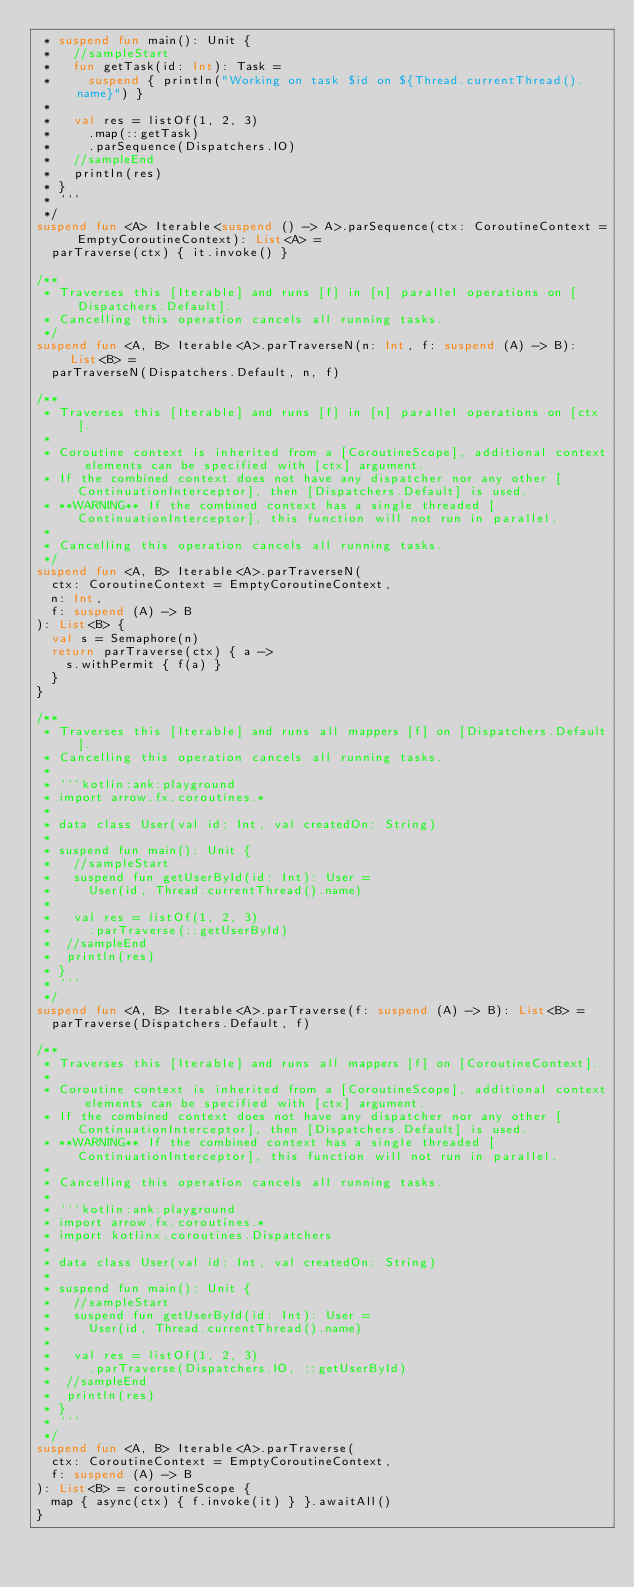Convert code to text. <code><loc_0><loc_0><loc_500><loc_500><_Kotlin_> * suspend fun main(): Unit {
 *   //sampleStart
 *   fun getTask(id: Int): Task =
 *     suspend { println("Working on task $id on ${Thread.currentThread().name}") }
 *
 *   val res = listOf(1, 2, 3)
 *     .map(::getTask)
 *     .parSequence(Dispatchers.IO)
 *   //sampleEnd
 *   println(res)
 * }
 * ```
 */
suspend fun <A> Iterable<suspend () -> A>.parSequence(ctx: CoroutineContext = EmptyCoroutineContext): List<A> =
  parTraverse(ctx) { it.invoke() }

/**
 * Traverses this [Iterable] and runs [f] in [n] parallel operations on [Dispatchers.Default].
 * Cancelling this operation cancels all running tasks.
 */
suspend fun <A, B> Iterable<A>.parTraverseN(n: Int, f: suspend (A) -> B): List<B> =
  parTraverseN(Dispatchers.Default, n, f)

/**
 * Traverses this [Iterable] and runs [f] in [n] parallel operations on [ctx].
 *
 * Coroutine context is inherited from a [CoroutineScope], additional context elements can be specified with [ctx] argument.
 * If the combined context does not have any dispatcher nor any other [ContinuationInterceptor], then [Dispatchers.Default] is used.
 * **WARNING** If the combined context has a single threaded [ContinuationInterceptor], this function will not run in parallel.
 *
 * Cancelling this operation cancels all running tasks.
 */
suspend fun <A, B> Iterable<A>.parTraverseN(
  ctx: CoroutineContext = EmptyCoroutineContext,
  n: Int,
  f: suspend (A) -> B
): List<B> {
  val s = Semaphore(n)
  return parTraverse(ctx) { a ->
    s.withPermit { f(a) }
  }
}

/**
 * Traverses this [Iterable] and runs all mappers [f] on [Dispatchers.Default].
 * Cancelling this operation cancels all running tasks.
 *
 * ```kotlin:ank:playground
 * import arrow.fx.coroutines.*
 *
 * data class User(val id: Int, val createdOn: String)
 *
 * suspend fun main(): Unit {
 *   //sampleStart
 *   suspend fun getUserById(id: Int): User =
 *     User(id, Thread.currentThread().name)
 *
 *   val res = listOf(1, 2, 3)
 *     .parTraverse(::getUserById)
 *  //sampleEnd
 *  println(res)
 * }
 * ```
 */
suspend fun <A, B> Iterable<A>.parTraverse(f: suspend (A) -> B): List<B> =
  parTraverse(Dispatchers.Default, f)

/**
 * Traverses this [Iterable] and runs all mappers [f] on [CoroutineContext].
 *
 * Coroutine context is inherited from a [CoroutineScope], additional context elements can be specified with [ctx] argument.
 * If the combined context does not have any dispatcher nor any other [ContinuationInterceptor], then [Dispatchers.Default] is used.
 * **WARNING** If the combined context has a single threaded [ContinuationInterceptor], this function will not run in parallel.
 *
 * Cancelling this operation cancels all running tasks.
 *
 * ```kotlin:ank:playground
 * import arrow.fx.coroutines.*
 * import kotlinx.coroutines.Dispatchers
 *
 * data class User(val id: Int, val createdOn: String)
 *
 * suspend fun main(): Unit {
 *   //sampleStart
 *   suspend fun getUserById(id: Int): User =
 *     User(id, Thread.currentThread().name)
 *
 *   val res = listOf(1, 2, 3)
 *     .parTraverse(Dispatchers.IO, ::getUserById)
 *  //sampleEnd
 *  println(res)
 * }
 * ```
 */
suspend fun <A, B> Iterable<A>.parTraverse(
  ctx: CoroutineContext = EmptyCoroutineContext,
  f: suspend (A) -> B
): List<B> = coroutineScope {
  map { async(ctx) { f.invoke(it) } }.awaitAll()
}
</code> 